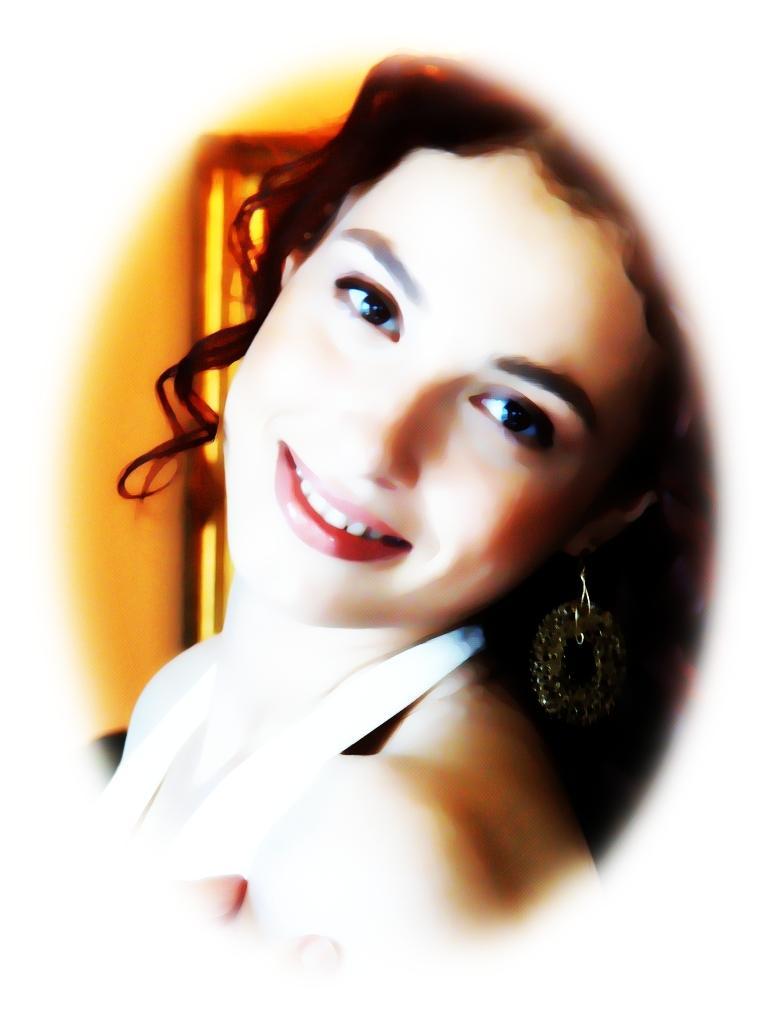In one or two sentences, can you explain what this image depicts? This image consists of a woman. It looks like it is clicked in a room. 